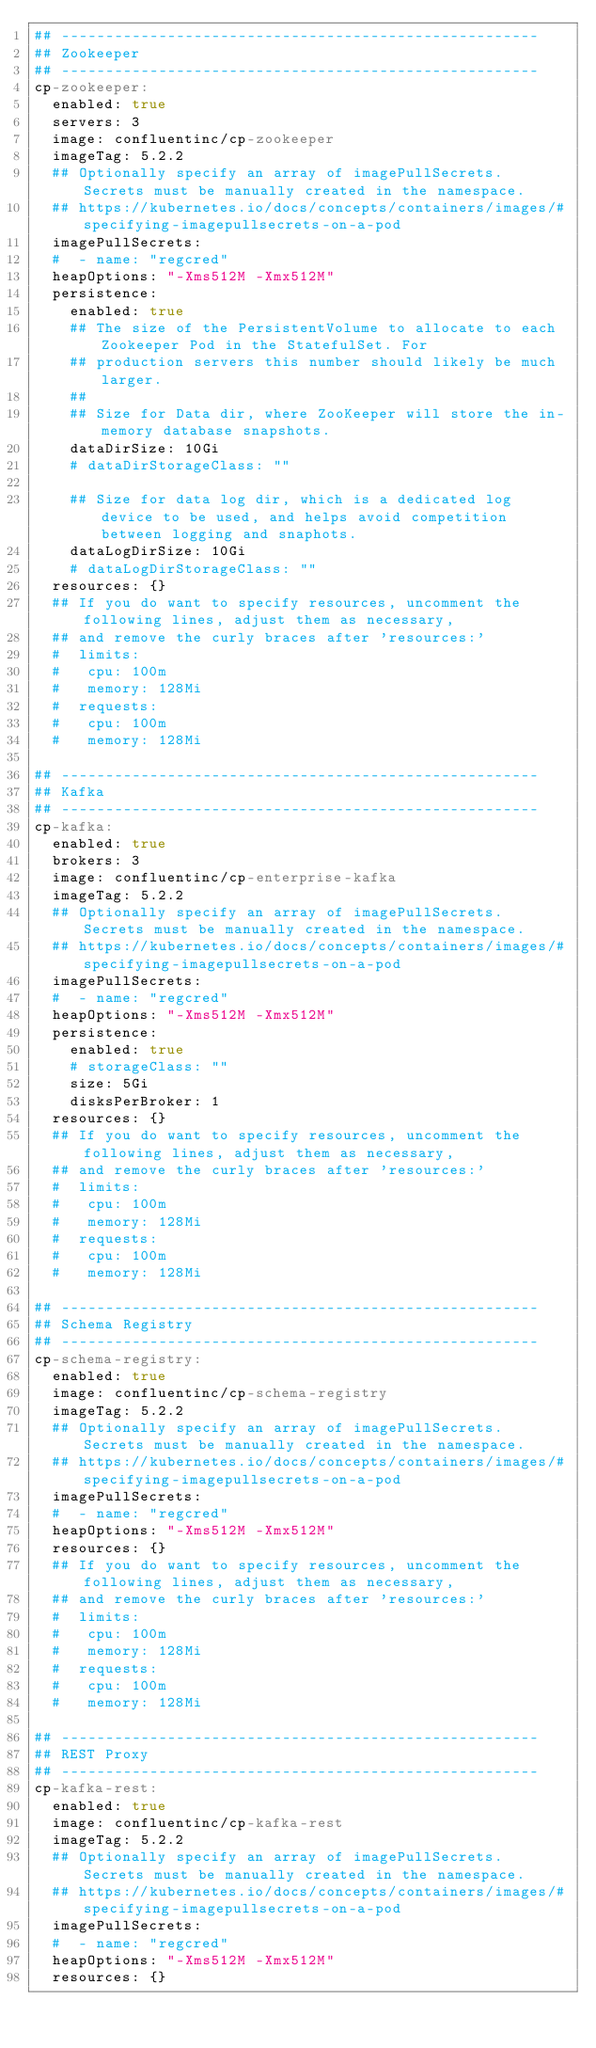Convert code to text. <code><loc_0><loc_0><loc_500><loc_500><_YAML_>## ------------------------------------------------------
## Zookeeper
## ------------------------------------------------------
cp-zookeeper:
  enabled: true
  servers: 3
  image: confluentinc/cp-zookeeper
  imageTag: 5.2.2
  ## Optionally specify an array of imagePullSecrets. Secrets must be manually created in the namespace.
  ## https://kubernetes.io/docs/concepts/containers/images/#specifying-imagepullsecrets-on-a-pod
  imagePullSecrets:
  #  - name: "regcred"
  heapOptions: "-Xms512M -Xmx512M"
  persistence:
    enabled: true
    ## The size of the PersistentVolume to allocate to each Zookeeper Pod in the StatefulSet. For
    ## production servers this number should likely be much larger.
    ##
    ## Size for Data dir, where ZooKeeper will store the in-memory database snapshots.
    dataDirSize: 10Gi
    # dataDirStorageClass: ""

    ## Size for data log dir, which is a dedicated log device to be used, and helps avoid competition between logging and snaphots.
    dataLogDirSize: 10Gi
    # dataLogDirStorageClass: ""
  resources: {}
  ## If you do want to specify resources, uncomment the following lines, adjust them as necessary,
  ## and remove the curly braces after 'resources:'
  #  limits:
  #   cpu: 100m
  #   memory: 128Mi
  #  requests:
  #   cpu: 100m
  #   memory: 128Mi

## ------------------------------------------------------
## Kafka
## ------------------------------------------------------
cp-kafka:
  enabled: true
  brokers: 3
  image: confluentinc/cp-enterprise-kafka
  imageTag: 5.2.2
  ## Optionally specify an array of imagePullSecrets. Secrets must be manually created in the namespace.
  ## https://kubernetes.io/docs/concepts/containers/images/#specifying-imagepullsecrets-on-a-pod
  imagePullSecrets:
  #  - name: "regcred"
  heapOptions: "-Xms512M -Xmx512M"
  persistence:
    enabled: true
    # storageClass: ""
    size: 5Gi
    disksPerBroker: 1
  resources: {}
  ## If you do want to specify resources, uncomment the following lines, adjust them as necessary,
  ## and remove the curly braces after 'resources:'
  #  limits:
  #   cpu: 100m
  #   memory: 128Mi
  #  requests:
  #   cpu: 100m
  #   memory: 128Mi

## ------------------------------------------------------
## Schema Registry
## ------------------------------------------------------
cp-schema-registry:
  enabled: true
  image: confluentinc/cp-schema-registry
  imageTag: 5.2.2
  ## Optionally specify an array of imagePullSecrets. Secrets must be manually created in the namespace.
  ## https://kubernetes.io/docs/concepts/containers/images/#specifying-imagepullsecrets-on-a-pod
  imagePullSecrets:
  #  - name: "regcred"
  heapOptions: "-Xms512M -Xmx512M"
  resources: {}
  ## If you do want to specify resources, uncomment the following lines, adjust them as necessary,
  ## and remove the curly braces after 'resources:'
  #  limits:
  #   cpu: 100m
  #   memory: 128Mi
  #  requests:
  #   cpu: 100m
  #   memory: 128Mi

## ------------------------------------------------------
## REST Proxy
## ------------------------------------------------------
cp-kafka-rest:
  enabled: true
  image: confluentinc/cp-kafka-rest
  imageTag: 5.2.2
  ## Optionally specify an array of imagePullSecrets. Secrets must be manually created in the namespace.
  ## https://kubernetes.io/docs/concepts/containers/images/#specifying-imagepullsecrets-on-a-pod
  imagePullSecrets:
  #  - name: "regcred"
  heapOptions: "-Xms512M -Xmx512M"
  resources: {}</code> 